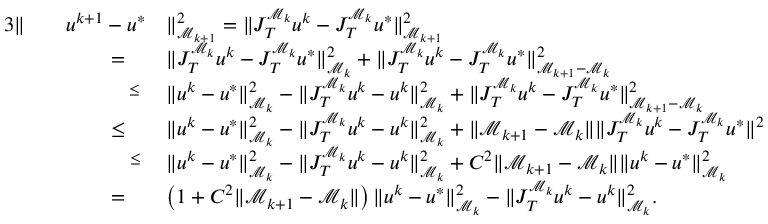Convert formula to latex. <formula><loc_0><loc_0><loc_500><loc_500>\begin{array} { r l r l } { { 3 } \| } & { u ^ { k + 1 } - u ^ { * } } & { \| _ { \mathcal { M } _ { k + 1 } } ^ { 2 } = \| J _ { T } ^ { \mathcal { M } _ { k } } u ^ { k } - J _ { T } ^ { \mathcal { M } _ { k } } u ^ { * } \| _ { \mathcal { M } _ { k + 1 } } ^ { 2 } } \\ & { = \quad } & { \| J _ { T } ^ { \mathcal { M } _ { k } } u ^ { k } - J _ { T } ^ { \mathcal { M } _ { k } } u ^ { * } \| _ { \mathcal { M } _ { k } } ^ { 2 } + \| J _ { T } ^ { \mathcal { M } _ { k } } u ^ { k } - J _ { T } ^ { \mathcal { M } _ { k } } u ^ { * } \| _ { \mathcal { M } _ { k + 1 } - \mathcal { M } _ { k } } ^ { 2 } } \\ & { \overset { \leq } \, } & { \| u ^ { k } - u ^ { * } \| _ { \mathcal { M } _ { k } } ^ { 2 } - \| J _ { T } ^ { \mathcal { M } _ { k } } u ^ { k } - u ^ { k } \| _ { \mathcal { M } _ { k } } ^ { 2 } + \| J _ { T } ^ { \mathcal { M } _ { k } } u ^ { k } - J _ { T } ^ { \mathcal { M } _ { k } } u ^ { * } \| _ { \mathcal { M } _ { k + 1 } - \mathcal { M } _ { k } } ^ { 2 } } \\ & { \leq \quad } & { \| u ^ { k } - u ^ { * } \| _ { \mathcal { M } _ { k } } ^ { 2 } - \| J _ { T } ^ { \mathcal { M } _ { k } } u ^ { k } - u ^ { k } \| _ { \mathcal { M } _ { k } } ^ { 2 } + \| \mathcal { M } _ { k + 1 } - \mathcal { M } _ { k } \| \| J _ { T } ^ { \mathcal { M } _ { k } } u ^ { k } - J _ { T } ^ { \mathcal { M } _ { k } } u ^ { * } \| ^ { 2 } } \\ & { \overset { \leq } \quad } & { \| u ^ { k } - u ^ { * } \| _ { \mathcal { M } _ { k } } ^ { 2 } - \| J _ { T } ^ { \mathcal { M } _ { k } } u ^ { k } - u ^ { k } \| _ { \mathcal { M } _ { k } } ^ { 2 } + C ^ { 2 } \| \mathcal { M } _ { k + 1 } - \mathcal { M } _ { k } \| \| u ^ { k } - u ^ { * } \| _ { \mathcal { M } _ { k } } ^ { 2 } } \\ & { = \quad } & { \left ( 1 + C ^ { 2 } \| \mathcal { M } _ { k + 1 } - \mathcal { M } _ { k } \| \right ) \| u ^ { k } - u ^ { * } \| _ { \mathcal { M } _ { k } } ^ { 2 } - \| J _ { T } ^ { \mathcal { M } _ { k } } u ^ { k } - u ^ { k } \| _ { \mathcal { M } _ { k } } ^ { 2 } . } \end{array}</formula> 